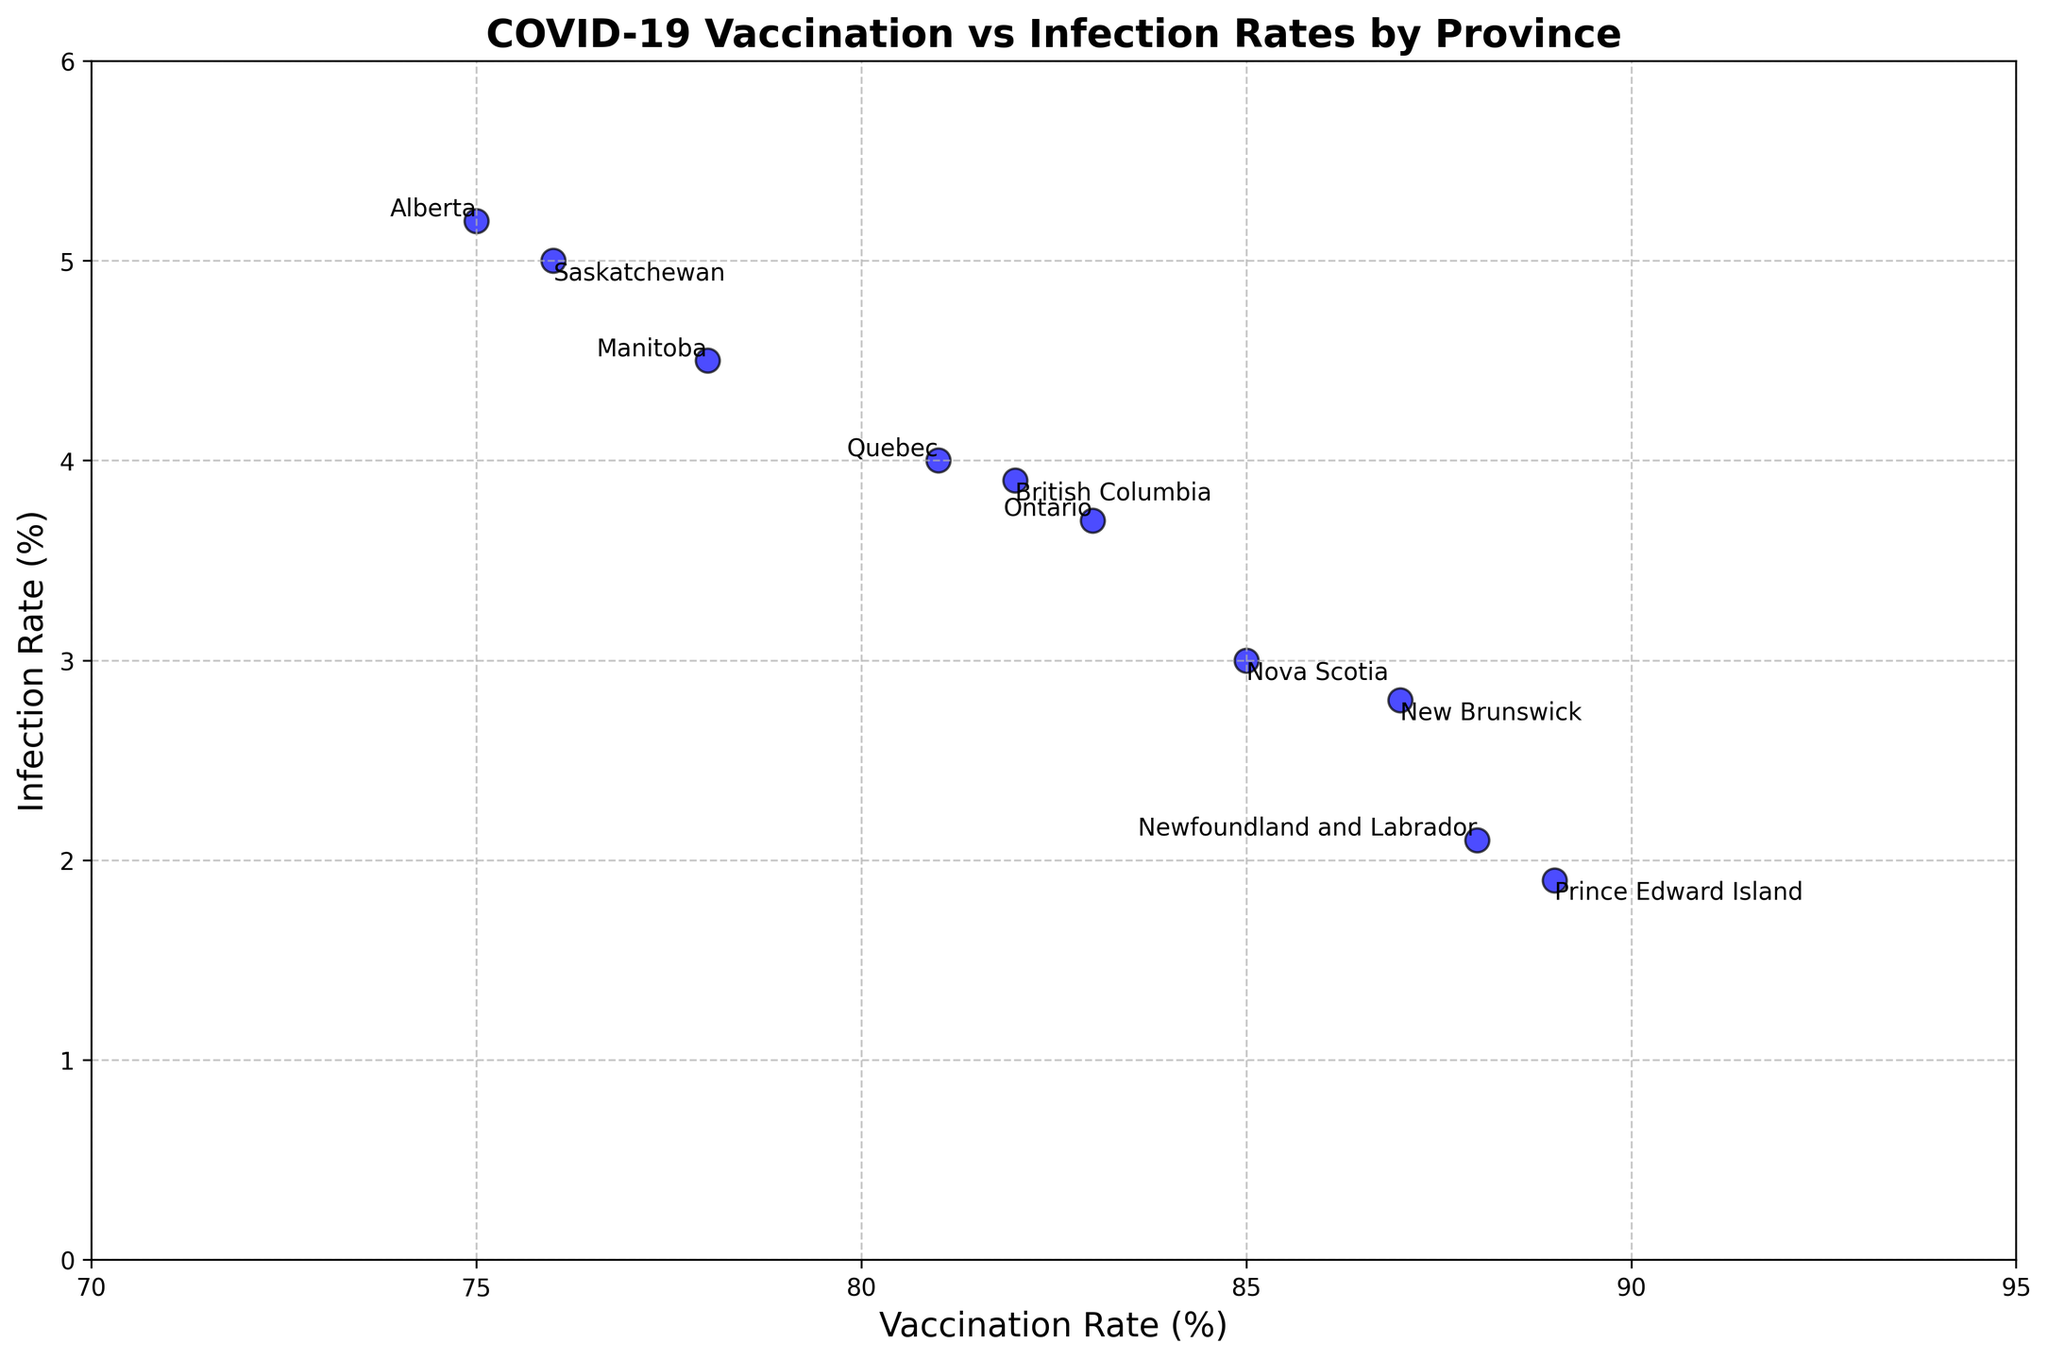What is the vaccination rate and infection rate for Alberta? Alberta has a vaccination rate of 75% and an infection rate of 5.2%. These values are directly labeled on the scatter plot for Alberta.
Answer: 75%, 5.2% Which province has the lowest infection rate, and what is that rate? The lowest infection rate is visible in the scatter plot, indicated by the province at the bottom with a rate of 1.9%. The label for this point is Prince Edward Island.
Answer: Prince Edward Island, 1.9% How many provinces have a vaccination rate above 80%? To answer this, count the number of data points to the right of the 80% mark on the x-axis. The provinces with vaccination rates above 80% are British Columbia, New Brunswick, Newfoundland and Labrador, Nova Scotia, Ontario, Quebec, and Prince Edward Island.
Answer: 7 Compare the infection rates of Saskatchewan and British Columbia. Which one is higher, and by how much? To compare the infection rates, locate the points for Saskatchewan and British Columbia on the scatter plot. Saskatchewan has an infection rate of 5.0%, while British Columbia has 3.9%. Subtract British Columbia's rate from Saskatchewan's to get 5.0% - 3.9% = 1.1%.
Answer: Saskatchewan, by 1.1% What is the average infection rate among the provinces? To find the average infection rate, sum the infection rates and divide by the number of provinces. The sum of infection rates is 5.2 + 3.9 + 4.5 + 2.8 + 2.1 + 3.0 + 3.7 + 1.9 + 4.0 + 5.0 = 36.1%. Dividing by 10 provinces gives 36.1 / 10 = 3.61%.
Answer: 3.61% Which provinces have both vaccination rates above 85% and infection rates below 3%? Find the provinces that meet both criteria by comparing the labeled points on the scatter plot. New Brunswick (87%, 2.8%), Newfoundland and Labrador (88%, 2.1%), and Prince Edward Island (89%, 1.9%) meet these criteria.
Answer: New Brunswick, Newfoundland and Labrador, Prince Edward Island By how much does the highest vaccination rate exceed the lowest vaccination rate, and which provinces correspond to these rates? The highest vaccination rate is 89% (Prince Edward Island), and the lowest is 75% (Alberta). The difference is 89% - 75% = 14%.
Answer: 14%, Prince Edward Island, Alberta What is the median infection rate among the provinces? To find the median, list the infection rates in ascending order: 1.9, 2.1, 2.8, 3.0, 3.7, 3.9, 4.0, 4.5, 5.0, 5.2. The median is the average of the middle two values (3.7 and 3.9), so (3.7 + 3.9) / 2 = 3.8.
Answer: 3.8% How does the infection rate of Ontario compare to that of Quebec? Locate Ontario's and Quebec's infection rates on the plot. Ontario has an infection rate of 3.7%, and Quebec has 4.0%. Ontario's rate is lower by 4.0% - 3.7% = 0.3%.
Answer: Ontario is lower by 0.3% Which province has the highest vaccination rate, and what is its corresponding infection rate? The province with the highest vaccination rate (89%) is Prince Edward Island, and its corresponding infection rate is 1.9%.
Answer: Prince Edward Island, 1.9% 